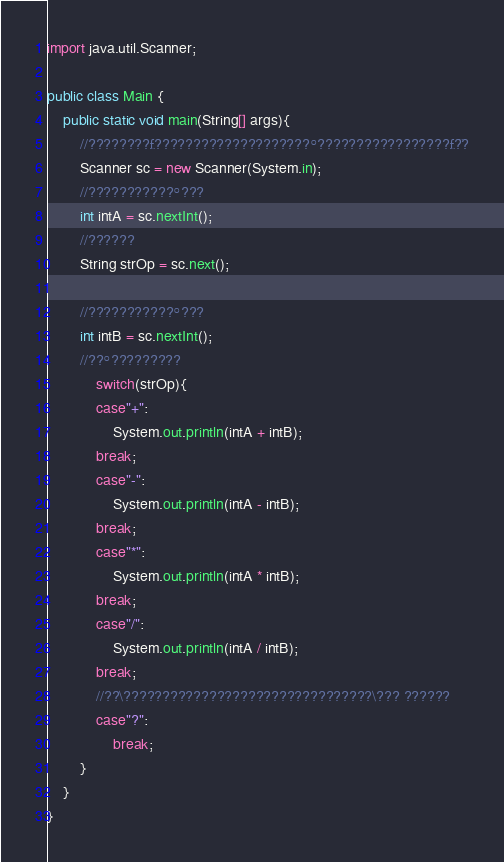<code> <loc_0><loc_0><loc_500><loc_500><_Java_>

import java.util.Scanner;

public class Main {
	public static void main(String[] args){
		//????????£????????????????????°?????????????????£?¨?
		Scanner sc = new Scanner(System.in);
		//???????????°???
		int intA = sc.nextInt();
		//??????
		String strOp = sc.next();

		//???????????°???
		int intB = sc.nextInt();
		//??°?????????
			switch(strOp){
			case"+":
				System.out.println(intA + intB);
			break;
			case"-":
				System.out.println(intA - intB);
			break;
			case"*":
				System.out.println(intA * intB);
			break;
			case"/":
				System.out.println(intA / intB);
			break;
			//??\????????????????????????????????\??? ??????
			case"?":
				break;
		}
	}
}</code> 